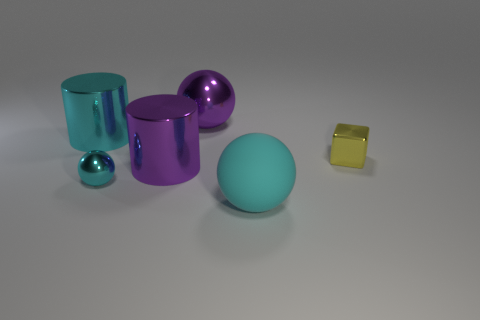Describe the lighting in the scene. The lighting in the image appears to be diffused and evenly distributed, with soft shadows gently outlining the bases of the objects. This creates a calm and harmonious atmosphere with no harsh reflections or contrasts. 